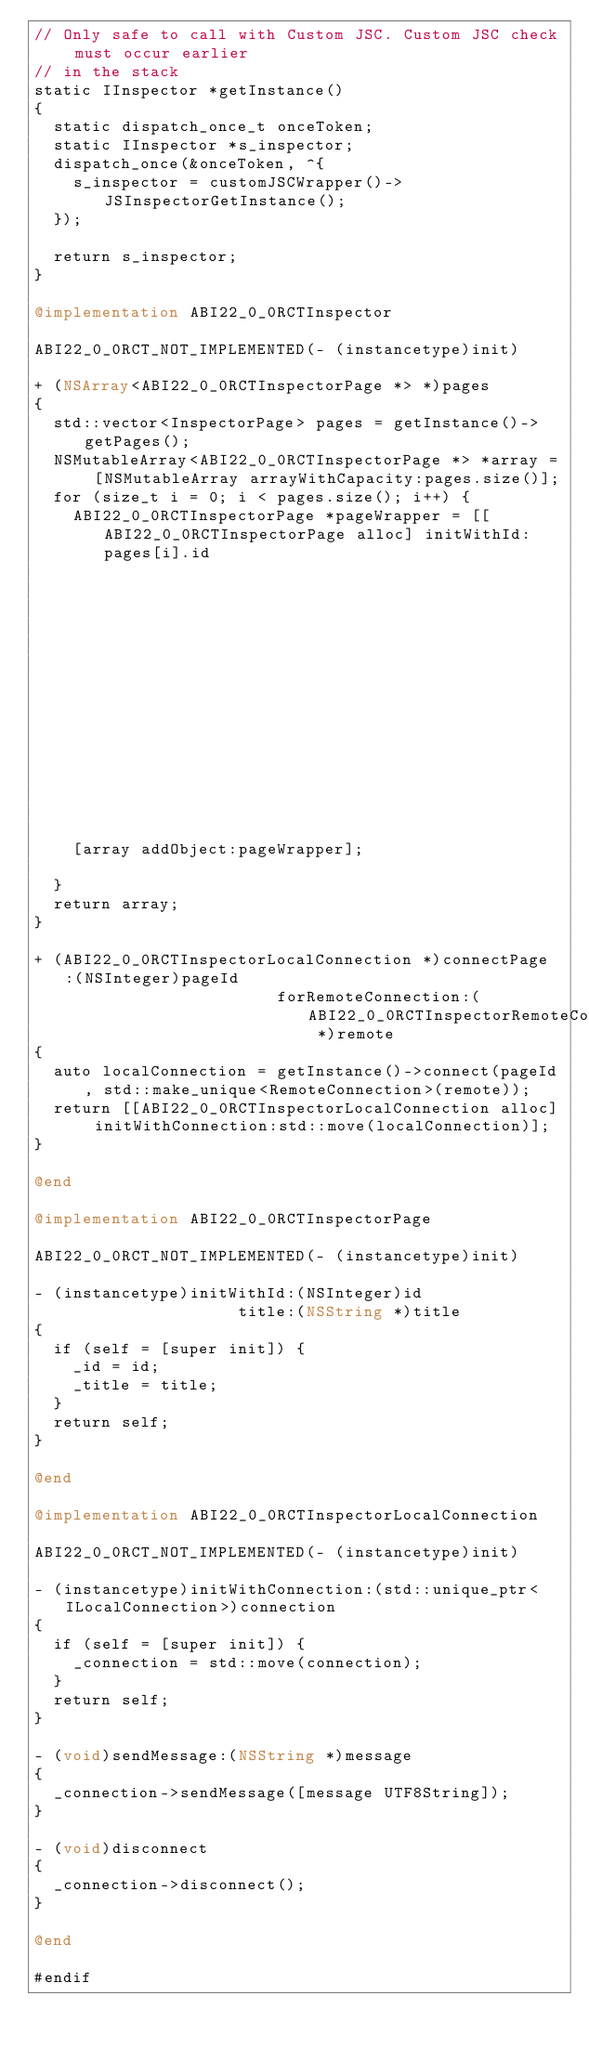<code> <loc_0><loc_0><loc_500><loc_500><_ObjectiveC_>// Only safe to call with Custom JSC. Custom JSC check must occur earlier
// in the stack
static IInspector *getInstance()
{
  static dispatch_once_t onceToken;
  static IInspector *s_inspector;
  dispatch_once(&onceToken, ^{
    s_inspector = customJSCWrapper()->JSInspectorGetInstance();
  });

  return s_inspector;
}

@implementation ABI22_0_0RCTInspector

ABI22_0_0RCT_NOT_IMPLEMENTED(- (instancetype)init)

+ (NSArray<ABI22_0_0RCTInspectorPage *> *)pages
{
  std::vector<InspectorPage> pages = getInstance()->getPages();
  NSMutableArray<ABI22_0_0RCTInspectorPage *> *array = [NSMutableArray arrayWithCapacity:pages.size()];
  for (size_t i = 0; i < pages.size(); i++) {
    ABI22_0_0RCTInspectorPage *pageWrapper = [[ABI22_0_0RCTInspectorPage alloc] initWithId:pages[i].id
                                                                   title:@(pages[i].title.c_str())];
    [array addObject:pageWrapper];

  }
  return array;
}

+ (ABI22_0_0RCTInspectorLocalConnection *)connectPage:(NSInteger)pageId
                         forRemoteConnection:(ABI22_0_0RCTInspectorRemoteConnection *)remote
{
  auto localConnection = getInstance()->connect(pageId, std::make_unique<RemoteConnection>(remote));
  return [[ABI22_0_0RCTInspectorLocalConnection alloc] initWithConnection:std::move(localConnection)];
}

@end

@implementation ABI22_0_0RCTInspectorPage

ABI22_0_0RCT_NOT_IMPLEMENTED(- (instancetype)init)

- (instancetype)initWithId:(NSInteger)id
                     title:(NSString *)title
{
  if (self = [super init]) {
    _id = id;
    _title = title;
  }
  return self;
}

@end

@implementation ABI22_0_0RCTInspectorLocalConnection

ABI22_0_0RCT_NOT_IMPLEMENTED(- (instancetype)init)

- (instancetype)initWithConnection:(std::unique_ptr<ILocalConnection>)connection
{
  if (self = [super init]) {
    _connection = std::move(connection);
  }
  return self;
}

- (void)sendMessage:(NSString *)message
{
  _connection->sendMessage([message UTF8String]);
}

- (void)disconnect
{
  _connection->disconnect();
}

@end

#endif
</code> 